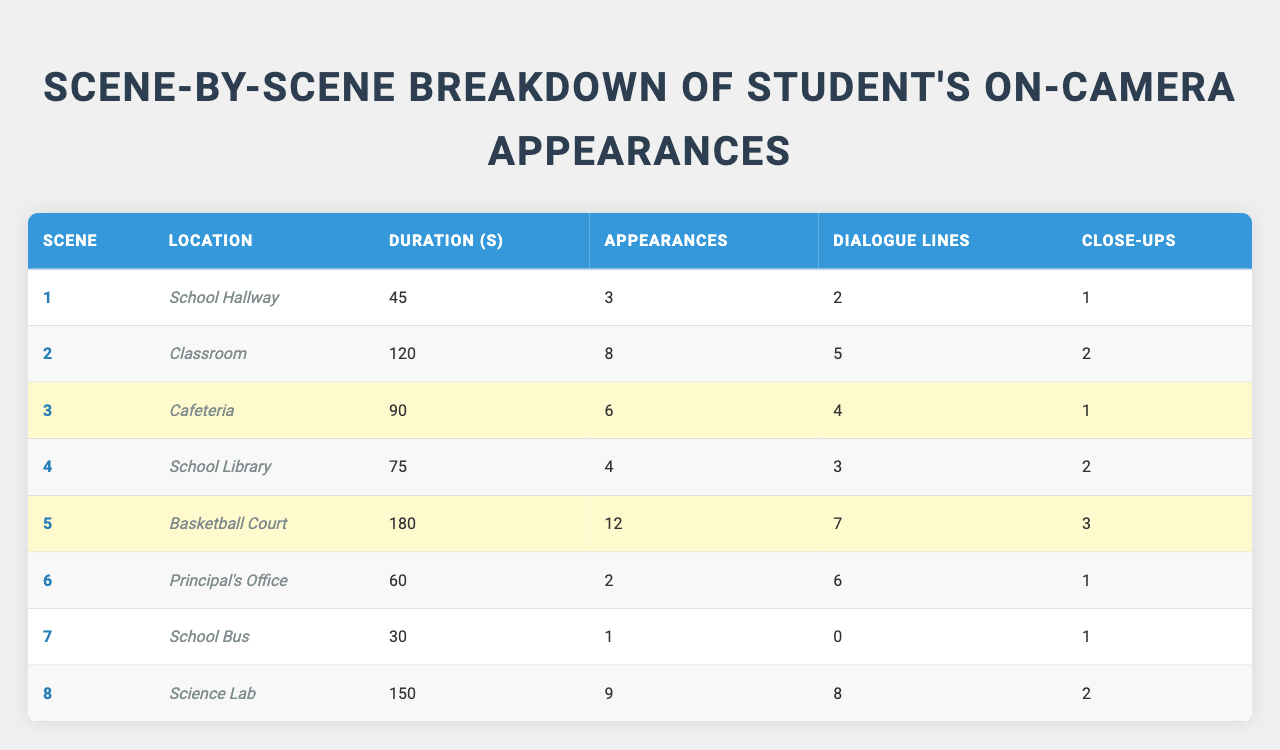What is the location for Scene 5? The table lists Scene 5 under the "Location" column, which shows "Basketball Court".
Answer: Basketball Court How many dialogue lines are there in Scene 2? In the table under Scene 2, the "Dialogue Lines" column shows the value of 5.
Answer: 5 What is the total duration of all scenes? The total duration is calculated by summing the duration of each scene: 45 + 120 + 90 + 75 + 180 + 60 + 30 + 150 = 750 seconds.
Answer: 750 seconds In how many scenes does the student appear more than 5 times? Reviewing the "Appearances" column, the scenes with more than 5 appearances are Scene 2 (8), Scene 5 (12), and Scene 8 (9), totaling 3 scenes.
Answer: 3 Which scene has the highest number of close-ups? Checking the "Close-Ups" column, Scene 5 has the highest number of close-ups with a value of 3.
Answer: Scene 5 What is the average duration of the scenes? We first find the total duration (750 seconds) and then divide by the number of scenes (8): 750 / 8 = 93.75 seconds average duration.
Answer: 93.75 seconds True or False: The student's lowest appearance was in Scene 7. Checking the "Appearances" column, Scene 7 has the lowest appearances at 1, confirming the statement is true.
Answer: True Which scene had the most dialogue lines and how many? Scene 8 has the most dialogue lines with a count of 8, according to the "Dialogue Lines" column.
Answer: Scene 8, 8 lines What is the difference in student appearances between Scene 5 and Scene 1? The difference is calculated as: 12 (Scene 5) - 3 (Scene 1) = 9.
Answer: 9 Is the student featured in more close-ups or dialogue lines across all scenes? The total close-ups sum to 10 and dialogue lines sum to 36. Since 36 > 10, there are more dialogue lines.
Answer: More dialogue lines 